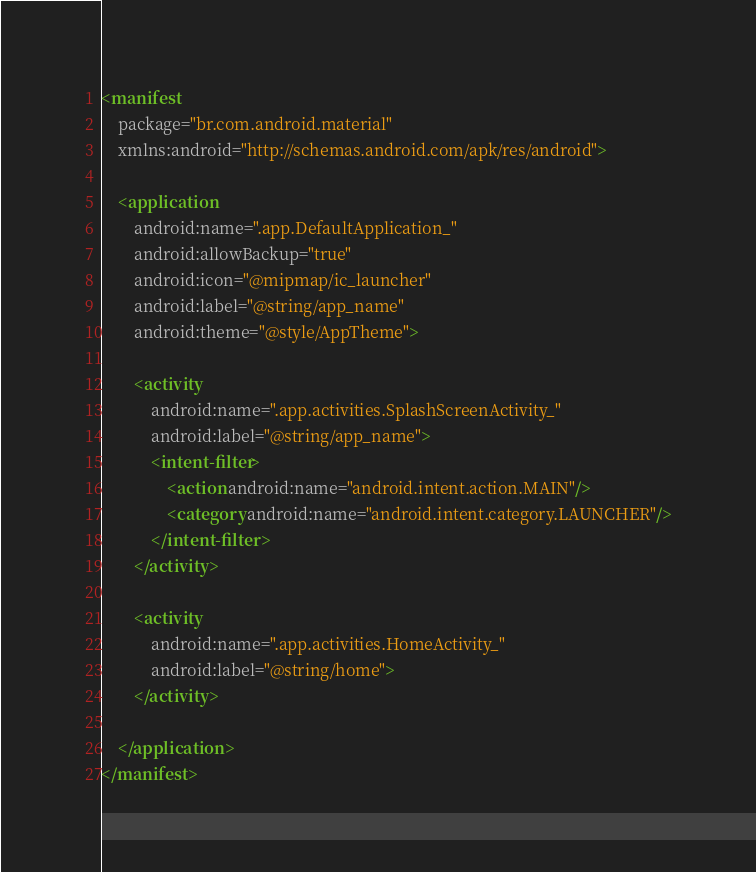Convert code to text. <code><loc_0><loc_0><loc_500><loc_500><_XML_><manifest
    package="br.com.android.material"
    xmlns:android="http://schemas.android.com/apk/res/android">

    <application
        android:name=".app.DefaultApplication_"
        android:allowBackup="true"
        android:icon="@mipmap/ic_launcher"
        android:label="@string/app_name"
        android:theme="@style/AppTheme">

        <activity
            android:name=".app.activities.SplashScreenActivity_"
            android:label="@string/app_name">
            <intent-filter>
                <action android:name="android.intent.action.MAIN"/>
                <category android:name="android.intent.category.LAUNCHER"/>
            </intent-filter>
        </activity>

        <activity
            android:name=".app.activities.HomeActivity_"
            android:label="@string/home">
        </activity>

    </application>
</manifest></code> 